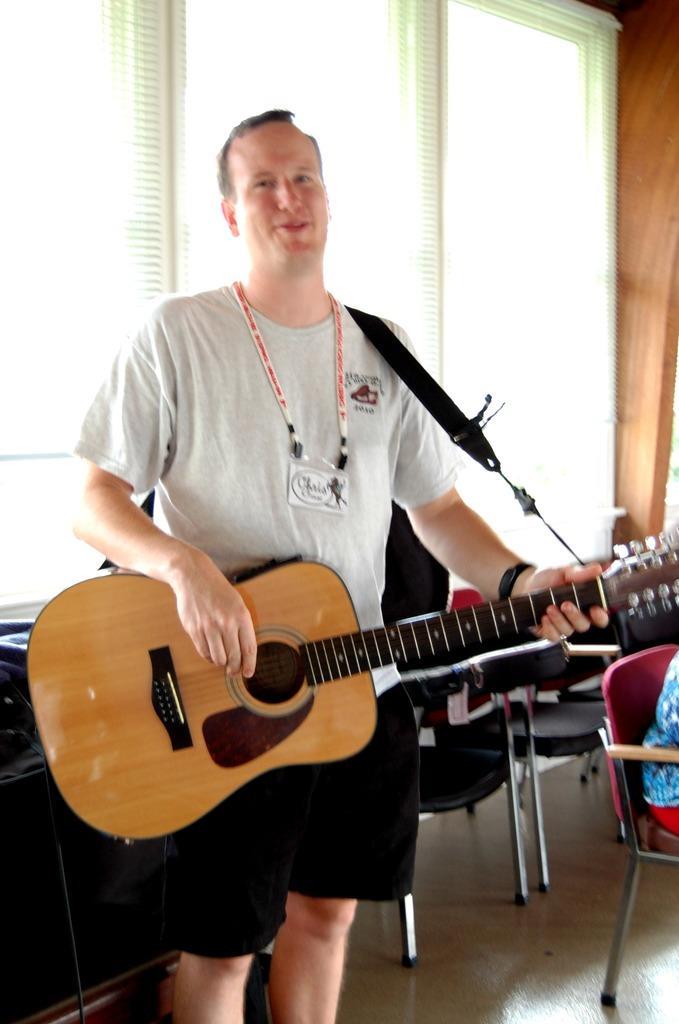In one or two sentences, can you explain what this image depicts? This man wore t-shirt, id card and playing guitar. Background we can able to see chairs, window and a table. Here a person is sitting on this red chair. 